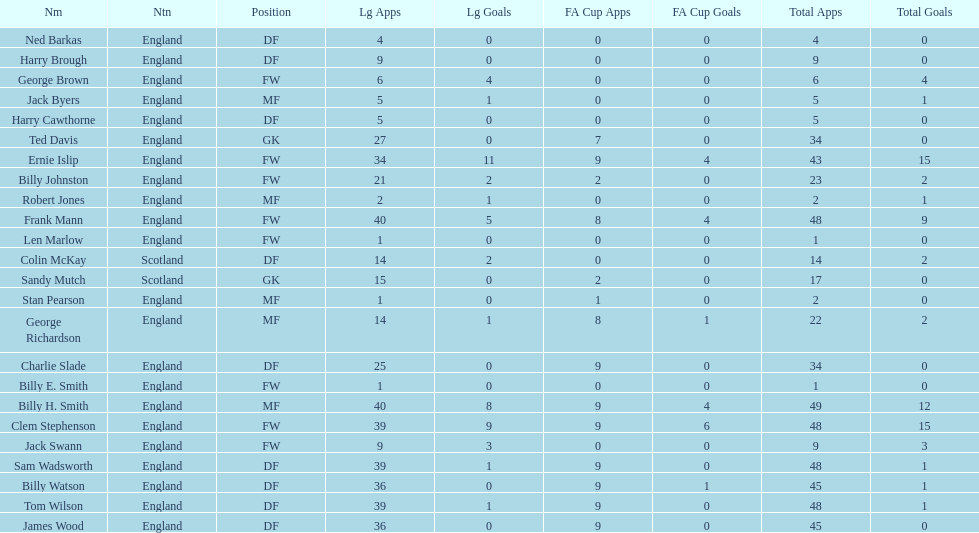Name the nation with the most appearances. England. 